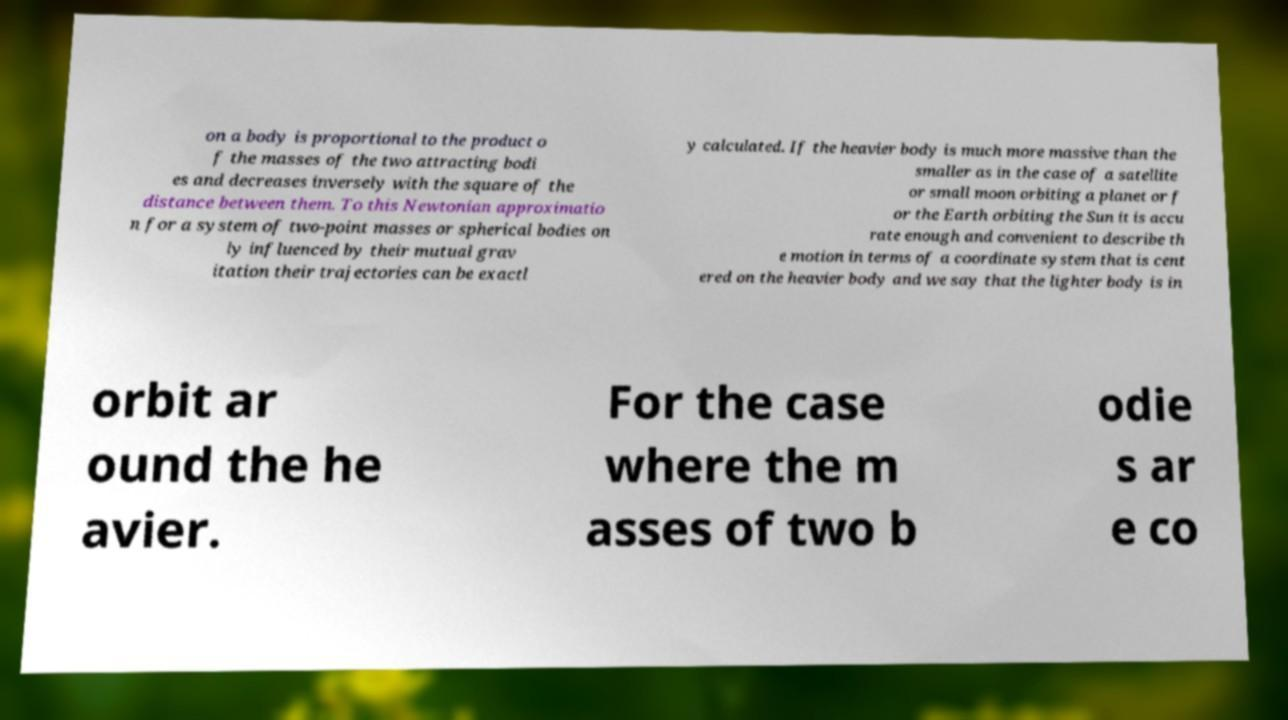For documentation purposes, I need the text within this image transcribed. Could you provide that? on a body is proportional to the product o f the masses of the two attracting bodi es and decreases inversely with the square of the distance between them. To this Newtonian approximatio n for a system of two-point masses or spherical bodies on ly influenced by their mutual grav itation their trajectories can be exactl y calculated. If the heavier body is much more massive than the smaller as in the case of a satellite or small moon orbiting a planet or f or the Earth orbiting the Sun it is accu rate enough and convenient to describe th e motion in terms of a coordinate system that is cent ered on the heavier body and we say that the lighter body is in orbit ar ound the he avier. For the case where the m asses of two b odie s ar e co 